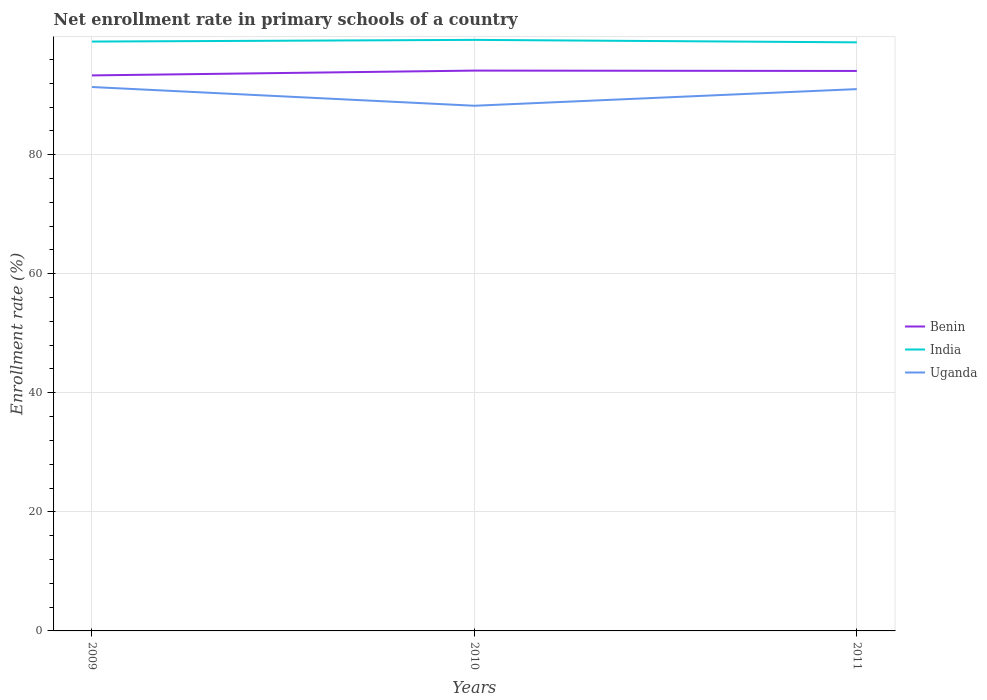How many different coloured lines are there?
Your response must be concise. 3. Does the line corresponding to Uganda intersect with the line corresponding to Benin?
Provide a succinct answer. No. Across all years, what is the maximum enrollment rate in primary schools in India?
Offer a very short reply. 98.87. In which year was the enrollment rate in primary schools in Uganda maximum?
Offer a very short reply. 2010. What is the total enrollment rate in primary schools in Benin in the graph?
Give a very brief answer. 0.06. What is the difference between the highest and the second highest enrollment rate in primary schools in India?
Provide a short and direct response. 0.42. How many lines are there?
Your response must be concise. 3. What is the difference between two consecutive major ticks on the Y-axis?
Make the answer very short. 20. Does the graph contain any zero values?
Offer a very short reply. No. How are the legend labels stacked?
Offer a terse response. Vertical. What is the title of the graph?
Offer a terse response. Net enrollment rate in primary schools of a country. What is the label or title of the X-axis?
Your answer should be very brief. Years. What is the label or title of the Y-axis?
Offer a very short reply. Enrollment rate (%). What is the Enrollment rate (%) in Benin in 2009?
Give a very brief answer. 93.31. What is the Enrollment rate (%) in India in 2009?
Give a very brief answer. 99. What is the Enrollment rate (%) of Uganda in 2009?
Offer a very short reply. 91.36. What is the Enrollment rate (%) in Benin in 2010?
Your answer should be very brief. 94.12. What is the Enrollment rate (%) of India in 2010?
Offer a very short reply. 99.28. What is the Enrollment rate (%) in Uganda in 2010?
Offer a terse response. 88.22. What is the Enrollment rate (%) of Benin in 2011?
Offer a terse response. 94.06. What is the Enrollment rate (%) of India in 2011?
Keep it short and to the point. 98.87. What is the Enrollment rate (%) of Uganda in 2011?
Make the answer very short. 91.01. Across all years, what is the maximum Enrollment rate (%) in Benin?
Offer a terse response. 94.12. Across all years, what is the maximum Enrollment rate (%) of India?
Your answer should be very brief. 99.28. Across all years, what is the maximum Enrollment rate (%) in Uganda?
Keep it short and to the point. 91.36. Across all years, what is the minimum Enrollment rate (%) of Benin?
Offer a very short reply. 93.31. Across all years, what is the minimum Enrollment rate (%) of India?
Provide a succinct answer. 98.87. Across all years, what is the minimum Enrollment rate (%) of Uganda?
Your answer should be very brief. 88.22. What is the total Enrollment rate (%) of Benin in the graph?
Give a very brief answer. 281.5. What is the total Enrollment rate (%) of India in the graph?
Provide a succinct answer. 297.15. What is the total Enrollment rate (%) of Uganda in the graph?
Your response must be concise. 270.59. What is the difference between the Enrollment rate (%) of Benin in 2009 and that in 2010?
Your answer should be compact. -0.81. What is the difference between the Enrollment rate (%) of India in 2009 and that in 2010?
Provide a short and direct response. -0.29. What is the difference between the Enrollment rate (%) in Uganda in 2009 and that in 2010?
Provide a short and direct response. 3.15. What is the difference between the Enrollment rate (%) of Benin in 2009 and that in 2011?
Ensure brevity in your answer.  -0.75. What is the difference between the Enrollment rate (%) in India in 2009 and that in 2011?
Your answer should be compact. 0.13. What is the difference between the Enrollment rate (%) of Uganda in 2009 and that in 2011?
Provide a succinct answer. 0.35. What is the difference between the Enrollment rate (%) of Benin in 2010 and that in 2011?
Your answer should be compact. 0.06. What is the difference between the Enrollment rate (%) of India in 2010 and that in 2011?
Your response must be concise. 0.42. What is the difference between the Enrollment rate (%) of Uganda in 2010 and that in 2011?
Keep it short and to the point. -2.8. What is the difference between the Enrollment rate (%) in Benin in 2009 and the Enrollment rate (%) in India in 2010?
Offer a very short reply. -5.97. What is the difference between the Enrollment rate (%) in Benin in 2009 and the Enrollment rate (%) in Uganda in 2010?
Give a very brief answer. 5.1. What is the difference between the Enrollment rate (%) of India in 2009 and the Enrollment rate (%) of Uganda in 2010?
Your answer should be very brief. 10.78. What is the difference between the Enrollment rate (%) of Benin in 2009 and the Enrollment rate (%) of India in 2011?
Provide a short and direct response. -5.55. What is the difference between the Enrollment rate (%) in Benin in 2009 and the Enrollment rate (%) in Uganda in 2011?
Your answer should be compact. 2.3. What is the difference between the Enrollment rate (%) of India in 2009 and the Enrollment rate (%) of Uganda in 2011?
Give a very brief answer. 7.98. What is the difference between the Enrollment rate (%) in Benin in 2010 and the Enrollment rate (%) in India in 2011?
Your response must be concise. -4.75. What is the difference between the Enrollment rate (%) in Benin in 2010 and the Enrollment rate (%) in Uganda in 2011?
Offer a terse response. 3.11. What is the difference between the Enrollment rate (%) in India in 2010 and the Enrollment rate (%) in Uganda in 2011?
Provide a short and direct response. 8.27. What is the average Enrollment rate (%) in Benin per year?
Ensure brevity in your answer.  93.83. What is the average Enrollment rate (%) of India per year?
Your answer should be compact. 99.05. What is the average Enrollment rate (%) in Uganda per year?
Offer a very short reply. 90.2. In the year 2009, what is the difference between the Enrollment rate (%) in Benin and Enrollment rate (%) in India?
Keep it short and to the point. -5.68. In the year 2009, what is the difference between the Enrollment rate (%) of Benin and Enrollment rate (%) of Uganda?
Provide a short and direct response. 1.95. In the year 2009, what is the difference between the Enrollment rate (%) of India and Enrollment rate (%) of Uganda?
Your answer should be very brief. 7.63. In the year 2010, what is the difference between the Enrollment rate (%) of Benin and Enrollment rate (%) of India?
Provide a short and direct response. -5.16. In the year 2010, what is the difference between the Enrollment rate (%) in Benin and Enrollment rate (%) in Uganda?
Ensure brevity in your answer.  5.9. In the year 2010, what is the difference between the Enrollment rate (%) of India and Enrollment rate (%) of Uganda?
Provide a succinct answer. 11.07. In the year 2011, what is the difference between the Enrollment rate (%) in Benin and Enrollment rate (%) in India?
Your response must be concise. -4.8. In the year 2011, what is the difference between the Enrollment rate (%) of Benin and Enrollment rate (%) of Uganda?
Provide a short and direct response. 3.05. In the year 2011, what is the difference between the Enrollment rate (%) in India and Enrollment rate (%) in Uganda?
Your answer should be compact. 7.85. What is the ratio of the Enrollment rate (%) of India in 2009 to that in 2010?
Your answer should be very brief. 1. What is the ratio of the Enrollment rate (%) of Uganda in 2009 to that in 2010?
Your answer should be compact. 1.04. What is the ratio of the Enrollment rate (%) of Uganda in 2009 to that in 2011?
Your answer should be very brief. 1. What is the ratio of the Enrollment rate (%) in India in 2010 to that in 2011?
Provide a short and direct response. 1. What is the ratio of the Enrollment rate (%) of Uganda in 2010 to that in 2011?
Your answer should be compact. 0.97. What is the difference between the highest and the second highest Enrollment rate (%) of Benin?
Ensure brevity in your answer.  0.06. What is the difference between the highest and the second highest Enrollment rate (%) of India?
Your answer should be very brief. 0.29. What is the difference between the highest and the second highest Enrollment rate (%) in Uganda?
Make the answer very short. 0.35. What is the difference between the highest and the lowest Enrollment rate (%) in Benin?
Keep it short and to the point. 0.81. What is the difference between the highest and the lowest Enrollment rate (%) in India?
Provide a short and direct response. 0.42. What is the difference between the highest and the lowest Enrollment rate (%) of Uganda?
Provide a succinct answer. 3.15. 